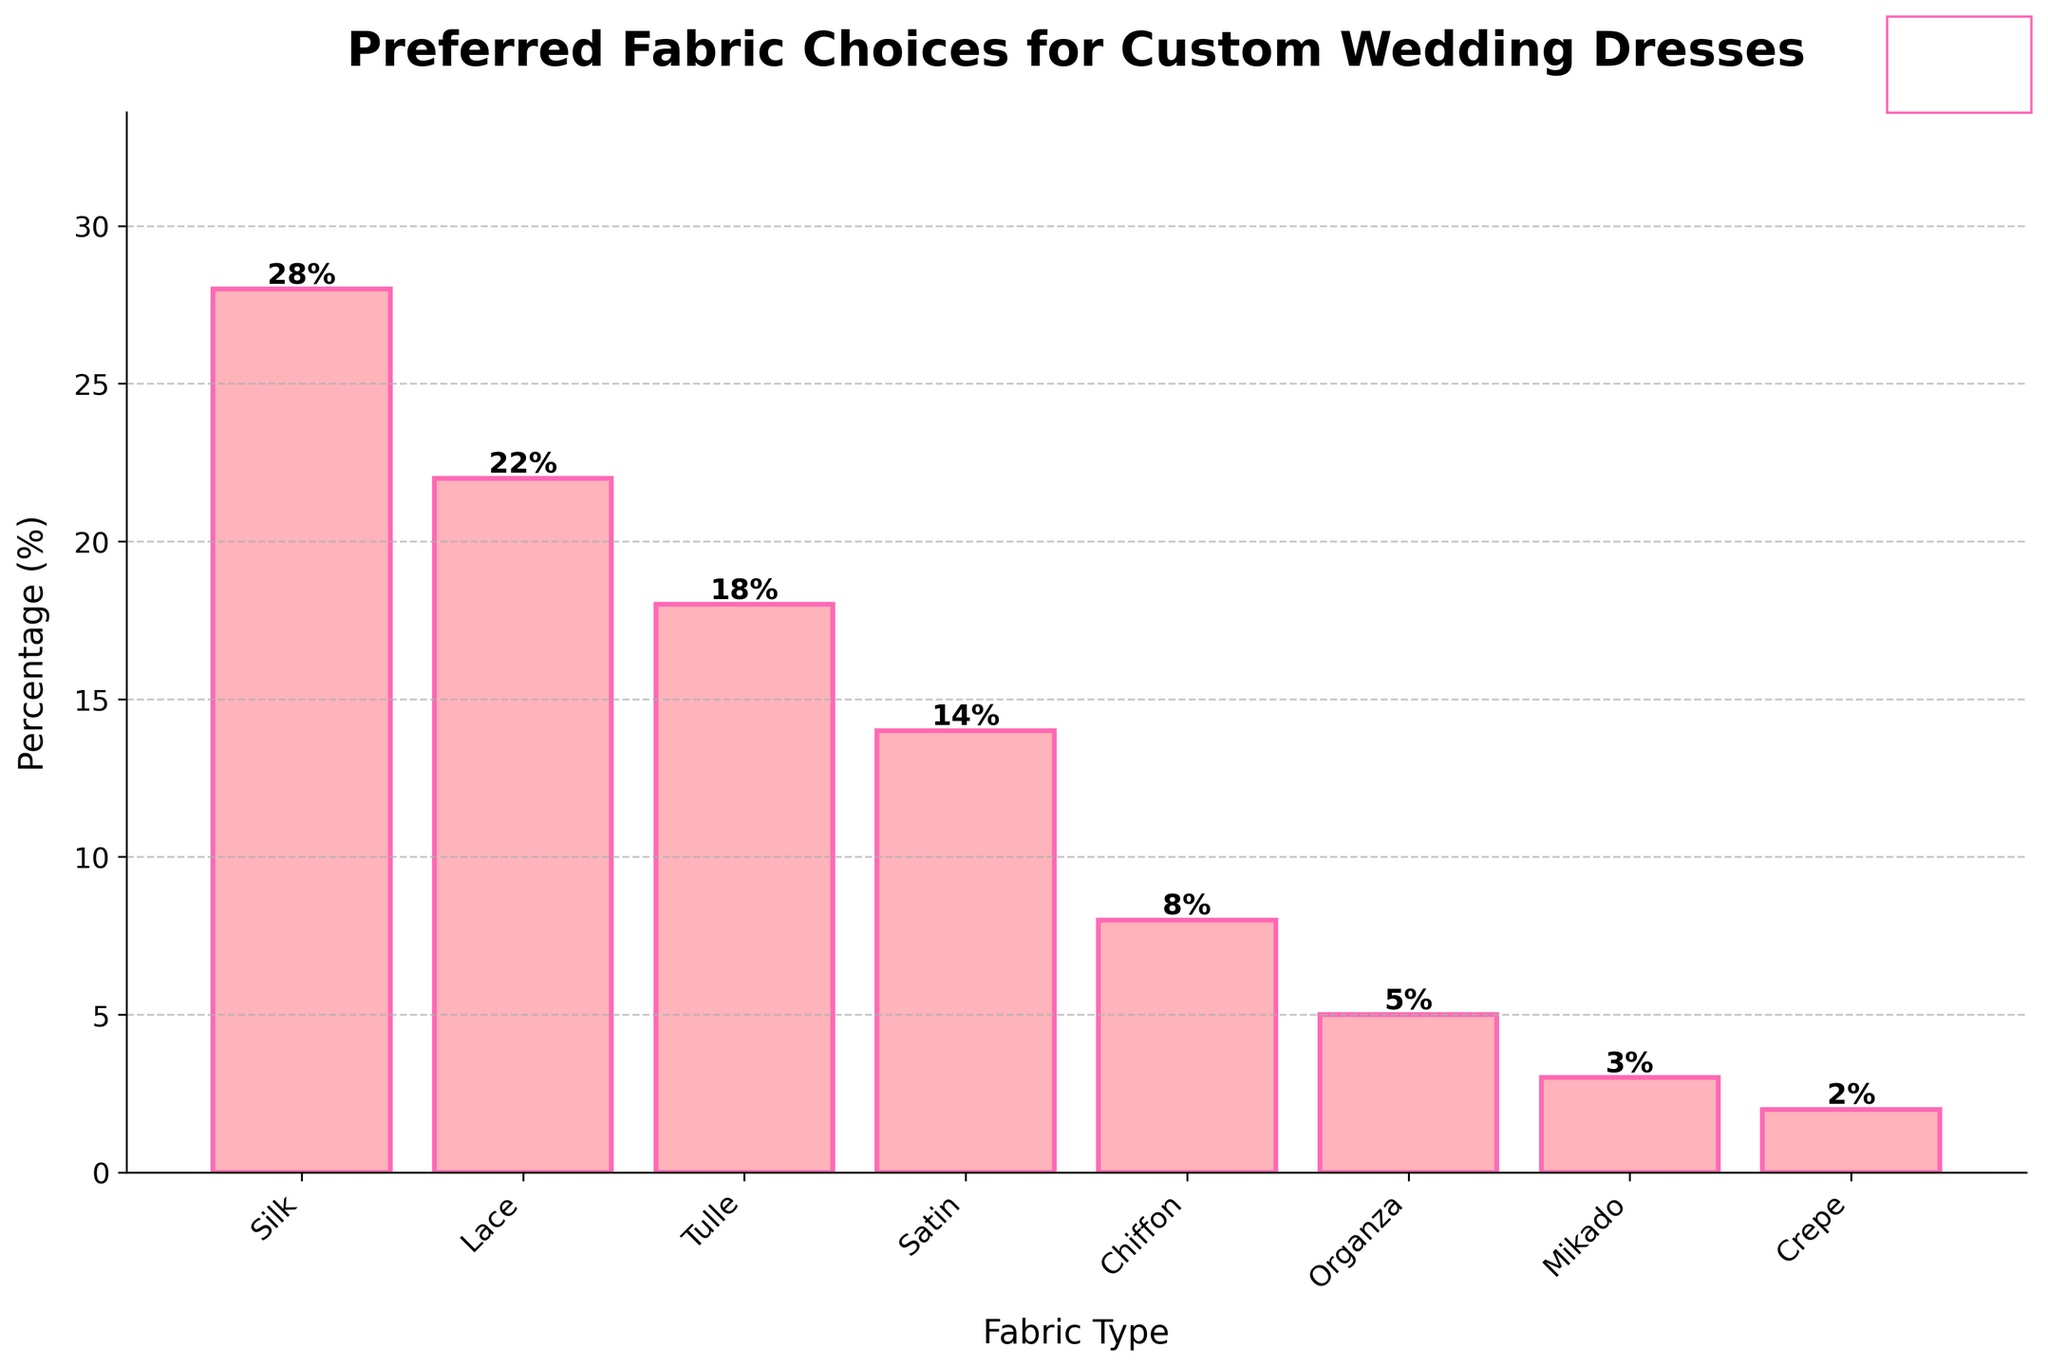What is the preferred fabric for custom wedding dresses according to the bar chart? The bar representing Silk is the highest among all the fabrics, indicating it is the most preferred.
Answer: Silk Which fabric type is preferred less, Organza or Mikado? The height of the bar for Mikado (3%) is less than that for Organza (5%).
Answer: Mikado By how much does Silk exceed Tulle in preference percentage? The percentage for Silk is 28% and for Tulle is 18%. The difference is 28% - 18% = 10%.
Answer: 10% Which fabric has a percentage closest to the average of Satin and Chiffon? The average preference of Satin (14%) and Chiffon (8%) is (14% + 8%) / 2 = 11%. Lace has 22%, which is not the closest. Organza has 5%, Crepe has 2%, Tulle has 18%. Thus, no fabric matches exactly or closely resembles 11%. The closest is Chiffon.
Answer: Chiffon What is the combined percentage of Lace and Crepe? Lace has 22% and Crepe has 2%. Their combined percentage is 22% + 2% = 24%.
Answer: 24% Among the fabrics listed, which one has the third highest preference? The bar heights in descending order are Silk (28%), Lace (22%), and then Tulle (18%).
Answer: Tulle Which fabric occupies the lowest percentage in preference? The shortest bar belongs to Crepe, which has a 2% preference.
Answer: Crepe Which two fabrics have a combined preference equal to that of Silk? Silk has a 28% preference. Organza (5%) and Mikado (3%) together make 8%. Tulle (18%) and Mikado (3%) make 21%. The correct combination is Lace (22%) and Chiffon (8%) with 22% + 8% = 30%. Thus, no exact combination matches exactly 28%, but the closest is Satin (14%) and Tulle (18%), totaling 32%.
Answer: None exactly. The closest combination is Satin and Tulle Which fabric is almost as visually prominent as Lace but still less preferred? Tulle has a percentage (18%) that is close to Lace (22%), but is still less preferred. Visually it comes second to Lace among others lower in the chart.
Answer: Tulle What is the total percentage of preferences for all the fabric types listed? Adding up all the percentages: 28% (Silk) + 22% (Lace) + 18% (Tulle) + 14% (Satin) + 8% (Chiffon) + 5% (Organza) + 3% (Mikado) + 2% (Crepe) = 100%.
Answer: 100% 